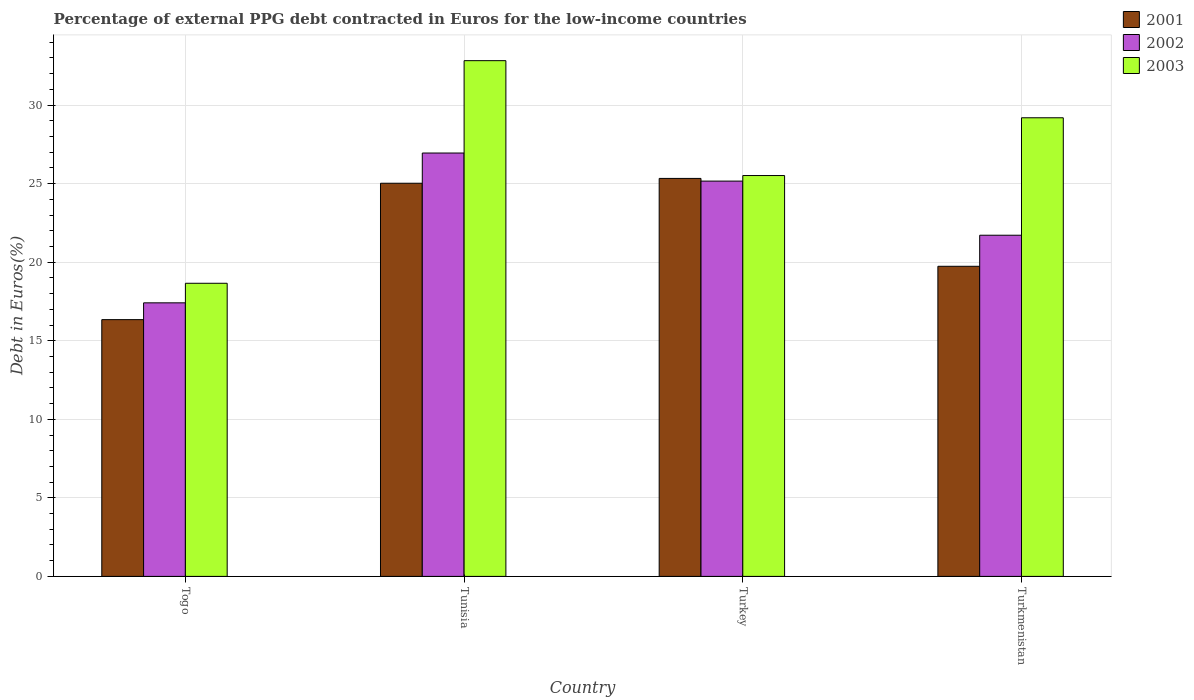Are the number of bars per tick equal to the number of legend labels?
Give a very brief answer. Yes. Are the number of bars on each tick of the X-axis equal?
Keep it short and to the point. Yes. How many bars are there on the 1st tick from the right?
Keep it short and to the point. 3. What is the label of the 1st group of bars from the left?
Offer a terse response. Togo. What is the percentage of external PPG debt contracted in Euros in 2003 in Togo?
Your answer should be very brief. 18.66. Across all countries, what is the maximum percentage of external PPG debt contracted in Euros in 2002?
Your response must be concise. 26.95. Across all countries, what is the minimum percentage of external PPG debt contracted in Euros in 2003?
Offer a terse response. 18.66. In which country was the percentage of external PPG debt contracted in Euros in 2003 maximum?
Make the answer very short. Tunisia. In which country was the percentage of external PPG debt contracted in Euros in 2003 minimum?
Provide a short and direct response. Togo. What is the total percentage of external PPG debt contracted in Euros in 2003 in the graph?
Make the answer very short. 106.2. What is the difference between the percentage of external PPG debt contracted in Euros in 2003 in Togo and that in Tunisia?
Provide a short and direct response. -14.17. What is the difference between the percentage of external PPG debt contracted in Euros in 2001 in Togo and the percentage of external PPG debt contracted in Euros in 2002 in Turkey?
Your answer should be compact. -8.82. What is the average percentage of external PPG debt contracted in Euros in 2002 per country?
Your answer should be very brief. 22.81. What is the difference between the percentage of external PPG debt contracted in Euros of/in 2002 and percentage of external PPG debt contracted in Euros of/in 2003 in Tunisia?
Offer a terse response. -5.88. What is the ratio of the percentage of external PPG debt contracted in Euros in 2002 in Tunisia to that in Turkmenistan?
Your answer should be very brief. 1.24. Is the percentage of external PPG debt contracted in Euros in 2003 in Togo less than that in Turkmenistan?
Give a very brief answer. Yes. Is the difference between the percentage of external PPG debt contracted in Euros in 2002 in Tunisia and Turkmenistan greater than the difference between the percentage of external PPG debt contracted in Euros in 2003 in Tunisia and Turkmenistan?
Your answer should be very brief. Yes. What is the difference between the highest and the second highest percentage of external PPG debt contracted in Euros in 2003?
Ensure brevity in your answer.  7.31. What is the difference between the highest and the lowest percentage of external PPG debt contracted in Euros in 2001?
Keep it short and to the point. 8.99. In how many countries, is the percentage of external PPG debt contracted in Euros in 2002 greater than the average percentage of external PPG debt contracted in Euros in 2002 taken over all countries?
Your response must be concise. 2. Is the sum of the percentage of external PPG debt contracted in Euros in 2002 in Turkey and Turkmenistan greater than the maximum percentage of external PPG debt contracted in Euros in 2003 across all countries?
Make the answer very short. Yes. What does the 1st bar from the right in Tunisia represents?
Provide a short and direct response. 2003. How many bars are there?
Make the answer very short. 12. Are all the bars in the graph horizontal?
Your answer should be compact. No. What is the difference between two consecutive major ticks on the Y-axis?
Your answer should be compact. 5. Does the graph contain grids?
Make the answer very short. Yes. How many legend labels are there?
Offer a terse response. 3. How are the legend labels stacked?
Provide a succinct answer. Vertical. What is the title of the graph?
Keep it short and to the point. Percentage of external PPG debt contracted in Euros for the low-income countries. What is the label or title of the Y-axis?
Your answer should be compact. Debt in Euros(%). What is the Debt in Euros(%) in 2001 in Togo?
Your response must be concise. 16.34. What is the Debt in Euros(%) in 2002 in Togo?
Your response must be concise. 17.41. What is the Debt in Euros(%) of 2003 in Togo?
Your answer should be compact. 18.66. What is the Debt in Euros(%) of 2001 in Tunisia?
Your response must be concise. 25.03. What is the Debt in Euros(%) in 2002 in Tunisia?
Ensure brevity in your answer.  26.95. What is the Debt in Euros(%) of 2003 in Tunisia?
Make the answer very short. 32.83. What is the Debt in Euros(%) in 2001 in Turkey?
Offer a very short reply. 25.33. What is the Debt in Euros(%) in 2002 in Turkey?
Provide a short and direct response. 25.16. What is the Debt in Euros(%) of 2003 in Turkey?
Provide a succinct answer. 25.52. What is the Debt in Euros(%) in 2001 in Turkmenistan?
Keep it short and to the point. 19.74. What is the Debt in Euros(%) of 2002 in Turkmenistan?
Your response must be concise. 21.72. What is the Debt in Euros(%) in 2003 in Turkmenistan?
Your answer should be very brief. 29.19. Across all countries, what is the maximum Debt in Euros(%) in 2001?
Ensure brevity in your answer.  25.33. Across all countries, what is the maximum Debt in Euros(%) of 2002?
Provide a short and direct response. 26.95. Across all countries, what is the maximum Debt in Euros(%) of 2003?
Your answer should be compact. 32.83. Across all countries, what is the minimum Debt in Euros(%) of 2001?
Offer a terse response. 16.34. Across all countries, what is the minimum Debt in Euros(%) in 2002?
Give a very brief answer. 17.41. Across all countries, what is the minimum Debt in Euros(%) of 2003?
Provide a succinct answer. 18.66. What is the total Debt in Euros(%) of 2001 in the graph?
Ensure brevity in your answer.  86.44. What is the total Debt in Euros(%) of 2002 in the graph?
Your answer should be compact. 91.24. What is the total Debt in Euros(%) of 2003 in the graph?
Provide a succinct answer. 106.2. What is the difference between the Debt in Euros(%) in 2001 in Togo and that in Tunisia?
Keep it short and to the point. -8.68. What is the difference between the Debt in Euros(%) in 2002 in Togo and that in Tunisia?
Offer a very short reply. -9.54. What is the difference between the Debt in Euros(%) of 2003 in Togo and that in Tunisia?
Your answer should be compact. -14.17. What is the difference between the Debt in Euros(%) in 2001 in Togo and that in Turkey?
Your answer should be compact. -8.99. What is the difference between the Debt in Euros(%) in 2002 in Togo and that in Turkey?
Make the answer very short. -7.75. What is the difference between the Debt in Euros(%) of 2003 in Togo and that in Turkey?
Offer a very short reply. -6.86. What is the difference between the Debt in Euros(%) of 2001 in Togo and that in Turkmenistan?
Offer a terse response. -3.4. What is the difference between the Debt in Euros(%) of 2002 in Togo and that in Turkmenistan?
Offer a terse response. -4.3. What is the difference between the Debt in Euros(%) of 2003 in Togo and that in Turkmenistan?
Ensure brevity in your answer.  -10.53. What is the difference between the Debt in Euros(%) of 2001 in Tunisia and that in Turkey?
Offer a terse response. -0.31. What is the difference between the Debt in Euros(%) in 2002 in Tunisia and that in Turkey?
Offer a very short reply. 1.79. What is the difference between the Debt in Euros(%) in 2003 in Tunisia and that in Turkey?
Provide a short and direct response. 7.31. What is the difference between the Debt in Euros(%) in 2001 in Tunisia and that in Turkmenistan?
Give a very brief answer. 5.29. What is the difference between the Debt in Euros(%) of 2002 in Tunisia and that in Turkmenistan?
Your answer should be very brief. 5.23. What is the difference between the Debt in Euros(%) in 2003 in Tunisia and that in Turkmenistan?
Your answer should be compact. 3.64. What is the difference between the Debt in Euros(%) in 2001 in Turkey and that in Turkmenistan?
Your response must be concise. 5.59. What is the difference between the Debt in Euros(%) in 2002 in Turkey and that in Turkmenistan?
Offer a terse response. 3.45. What is the difference between the Debt in Euros(%) of 2003 in Turkey and that in Turkmenistan?
Make the answer very short. -3.68. What is the difference between the Debt in Euros(%) in 2001 in Togo and the Debt in Euros(%) in 2002 in Tunisia?
Provide a succinct answer. -10.61. What is the difference between the Debt in Euros(%) of 2001 in Togo and the Debt in Euros(%) of 2003 in Tunisia?
Keep it short and to the point. -16.48. What is the difference between the Debt in Euros(%) of 2002 in Togo and the Debt in Euros(%) of 2003 in Tunisia?
Your answer should be compact. -15.42. What is the difference between the Debt in Euros(%) in 2001 in Togo and the Debt in Euros(%) in 2002 in Turkey?
Provide a succinct answer. -8.82. What is the difference between the Debt in Euros(%) in 2001 in Togo and the Debt in Euros(%) in 2003 in Turkey?
Make the answer very short. -9.17. What is the difference between the Debt in Euros(%) in 2002 in Togo and the Debt in Euros(%) in 2003 in Turkey?
Give a very brief answer. -8.1. What is the difference between the Debt in Euros(%) in 2001 in Togo and the Debt in Euros(%) in 2002 in Turkmenistan?
Make the answer very short. -5.37. What is the difference between the Debt in Euros(%) in 2001 in Togo and the Debt in Euros(%) in 2003 in Turkmenistan?
Your answer should be very brief. -12.85. What is the difference between the Debt in Euros(%) of 2002 in Togo and the Debt in Euros(%) of 2003 in Turkmenistan?
Your response must be concise. -11.78. What is the difference between the Debt in Euros(%) of 2001 in Tunisia and the Debt in Euros(%) of 2002 in Turkey?
Your answer should be very brief. -0.14. What is the difference between the Debt in Euros(%) in 2001 in Tunisia and the Debt in Euros(%) in 2003 in Turkey?
Offer a terse response. -0.49. What is the difference between the Debt in Euros(%) in 2002 in Tunisia and the Debt in Euros(%) in 2003 in Turkey?
Your response must be concise. 1.43. What is the difference between the Debt in Euros(%) in 2001 in Tunisia and the Debt in Euros(%) in 2002 in Turkmenistan?
Keep it short and to the point. 3.31. What is the difference between the Debt in Euros(%) in 2001 in Tunisia and the Debt in Euros(%) in 2003 in Turkmenistan?
Your answer should be very brief. -4.17. What is the difference between the Debt in Euros(%) of 2002 in Tunisia and the Debt in Euros(%) of 2003 in Turkmenistan?
Provide a succinct answer. -2.24. What is the difference between the Debt in Euros(%) of 2001 in Turkey and the Debt in Euros(%) of 2002 in Turkmenistan?
Your answer should be compact. 3.62. What is the difference between the Debt in Euros(%) in 2001 in Turkey and the Debt in Euros(%) in 2003 in Turkmenistan?
Offer a very short reply. -3.86. What is the difference between the Debt in Euros(%) of 2002 in Turkey and the Debt in Euros(%) of 2003 in Turkmenistan?
Your answer should be very brief. -4.03. What is the average Debt in Euros(%) in 2001 per country?
Provide a short and direct response. 21.61. What is the average Debt in Euros(%) in 2002 per country?
Provide a succinct answer. 22.81. What is the average Debt in Euros(%) of 2003 per country?
Offer a very short reply. 26.55. What is the difference between the Debt in Euros(%) of 2001 and Debt in Euros(%) of 2002 in Togo?
Your response must be concise. -1.07. What is the difference between the Debt in Euros(%) in 2001 and Debt in Euros(%) in 2003 in Togo?
Keep it short and to the point. -2.31. What is the difference between the Debt in Euros(%) of 2002 and Debt in Euros(%) of 2003 in Togo?
Offer a very short reply. -1.25. What is the difference between the Debt in Euros(%) of 2001 and Debt in Euros(%) of 2002 in Tunisia?
Provide a short and direct response. -1.92. What is the difference between the Debt in Euros(%) in 2001 and Debt in Euros(%) in 2003 in Tunisia?
Make the answer very short. -7.8. What is the difference between the Debt in Euros(%) of 2002 and Debt in Euros(%) of 2003 in Tunisia?
Your response must be concise. -5.88. What is the difference between the Debt in Euros(%) of 2001 and Debt in Euros(%) of 2002 in Turkey?
Keep it short and to the point. 0.17. What is the difference between the Debt in Euros(%) of 2001 and Debt in Euros(%) of 2003 in Turkey?
Your answer should be very brief. -0.18. What is the difference between the Debt in Euros(%) of 2002 and Debt in Euros(%) of 2003 in Turkey?
Provide a short and direct response. -0.35. What is the difference between the Debt in Euros(%) in 2001 and Debt in Euros(%) in 2002 in Turkmenistan?
Keep it short and to the point. -1.98. What is the difference between the Debt in Euros(%) of 2001 and Debt in Euros(%) of 2003 in Turkmenistan?
Your answer should be compact. -9.45. What is the difference between the Debt in Euros(%) in 2002 and Debt in Euros(%) in 2003 in Turkmenistan?
Offer a very short reply. -7.48. What is the ratio of the Debt in Euros(%) in 2001 in Togo to that in Tunisia?
Give a very brief answer. 0.65. What is the ratio of the Debt in Euros(%) of 2002 in Togo to that in Tunisia?
Give a very brief answer. 0.65. What is the ratio of the Debt in Euros(%) in 2003 in Togo to that in Tunisia?
Ensure brevity in your answer.  0.57. What is the ratio of the Debt in Euros(%) of 2001 in Togo to that in Turkey?
Make the answer very short. 0.65. What is the ratio of the Debt in Euros(%) of 2002 in Togo to that in Turkey?
Offer a terse response. 0.69. What is the ratio of the Debt in Euros(%) in 2003 in Togo to that in Turkey?
Give a very brief answer. 0.73. What is the ratio of the Debt in Euros(%) of 2001 in Togo to that in Turkmenistan?
Give a very brief answer. 0.83. What is the ratio of the Debt in Euros(%) in 2002 in Togo to that in Turkmenistan?
Provide a succinct answer. 0.8. What is the ratio of the Debt in Euros(%) of 2003 in Togo to that in Turkmenistan?
Offer a terse response. 0.64. What is the ratio of the Debt in Euros(%) of 2001 in Tunisia to that in Turkey?
Your answer should be compact. 0.99. What is the ratio of the Debt in Euros(%) of 2002 in Tunisia to that in Turkey?
Make the answer very short. 1.07. What is the ratio of the Debt in Euros(%) of 2003 in Tunisia to that in Turkey?
Ensure brevity in your answer.  1.29. What is the ratio of the Debt in Euros(%) of 2001 in Tunisia to that in Turkmenistan?
Your answer should be compact. 1.27. What is the ratio of the Debt in Euros(%) of 2002 in Tunisia to that in Turkmenistan?
Your answer should be very brief. 1.24. What is the ratio of the Debt in Euros(%) in 2003 in Tunisia to that in Turkmenistan?
Provide a succinct answer. 1.12. What is the ratio of the Debt in Euros(%) in 2001 in Turkey to that in Turkmenistan?
Keep it short and to the point. 1.28. What is the ratio of the Debt in Euros(%) of 2002 in Turkey to that in Turkmenistan?
Provide a succinct answer. 1.16. What is the ratio of the Debt in Euros(%) in 2003 in Turkey to that in Turkmenistan?
Keep it short and to the point. 0.87. What is the difference between the highest and the second highest Debt in Euros(%) of 2001?
Provide a short and direct response. 0.31. What is the difference between the highest and the second highest Debt in Euros(%) of 2002?
Provide a succinct answer. 1.79. What is the difference between the highest and the second highest Debt in Euros(%) of 2003?
Ensure brevity in your answer.  3.64. What is the difference between the highest and the lowest Debt in Euros(%) of 2001?
Offer a very short reply. 8.99. What is the difference between the highest and the lowest Debt in Euros(%) in 2002?
Your response must be concise. 9.54. What is the difference between the highest and the lowest Debt in Euros(%) of 2003?
Your answer should be compact. 14.17. 